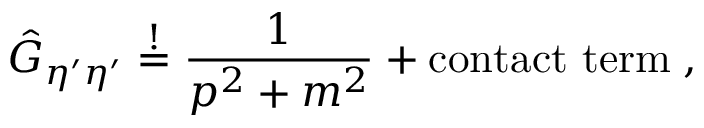Convert formula to latex. <formula><loc_0><loc_0><loc_500><loc_500>\hat { G } _ { \eta ^ { \prime } \eta ^ { \prime } } \stackrel { ! } { = } \frac { 1 } { p ^ { 2 } + m ^ { 2 } } + c o n t a c t t e r m \, ,</formula> 